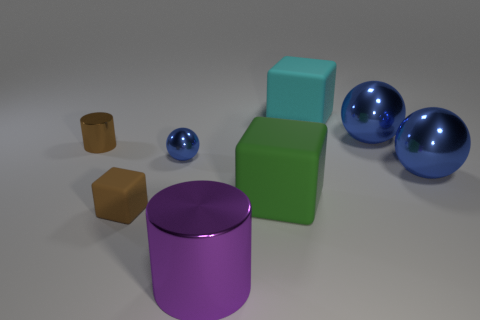There is a brown block that is the same size as the brown metal cylinder; what material is it?
Give a very brief answer. Rubber. There is a big metal object that is behind the sphere on the left side of the purple shiny thing that is in front of the tiny shiny cylinder; what color is it?
Provide a succinct answer. Blue. Does the small brown thing behind the green matte thing have the same shape as the blue object that is in front of the tiny blue metal thing?
Provide a succinct answer. No. How many tiny red metal things are there?
Offer a very short reply. 0. The metal cylinder that is the same size as the brown matte block is what color?
Your answer should be compact. Brown. Does the cylinder behind the brown cube have the same material as the ball on the left side of the cyan rubber object?
Offer a very short reply. Yes. There is a rubber thing that is left of the large rubber cube that is in front of the large cyan thing; what is its size?
Your answer should be very brief. Small. What is the tiny brown thing that is behind the brown matte block made of?
Ensure brevity in your answer.  Metal. What number of things are rubber cubes that are right of the big purple cylinder or things that are behind the tiny brown rubber block?
Your answer should be very brief. 6. There is a big purple object that is the same shape as the tiny brown metal object; what material is it?
Make the answer very short. Metal. 